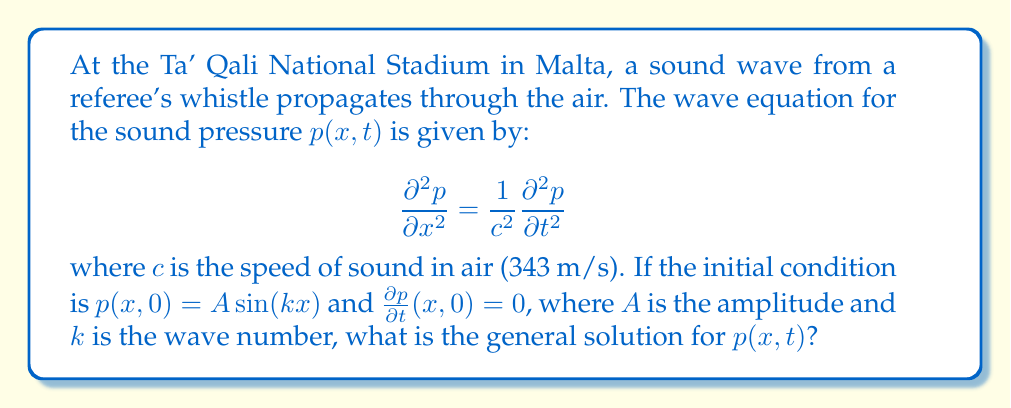Solve this math problem. To solve this wave equation problem, we'll follow these steps:

1) The general solution for the 1D wave equation is of the form:
   
   $$p(x,t) = f(x-ct) + g(x+ct)$$

   where $f$ and $g$ are arbitrary functions.

2) Given the initial condition $p(x,0) = A\sin(kx)$, we can write:
   
   $$f(x) + g(x) = A\sin(kx)$$

3) The second initial condition $\frac{\partial p}{\partial t}(x,0) = 0$ implies:
   
   $$-cf'(x) + cg'(x) = 0$$
   
   or $f'(x) = g'(x)$

4) From steps 2 and 3, we can deduce:
   
   $$f(x) = g(x) = \frac{A}{2}\sin(kx)$$

5) Substituting these into the general solution:

   $$p(x,t) = \frac{A}{2}\sin(k(x-ct)) + \frac{A}{2}\sin(k(x+ct))$$

6) Using the trigonometric identity for the sum of sines:

   $$\sin(a) + \sin(b) = 2\sin(\frac{a+b}{2})\cos(\frac{a-b}{2})$$

7) We get the final solution:

   $$p(x,t) = A\sin(kx)\cos(kct)$$

This solution represents a standing wave, which is a superposition of two traveling waves moving in opposite directions.
Answer: $p(x,t) = A\sin(kx)\cos(kct)$ 